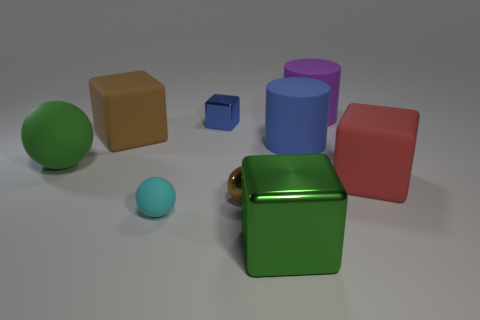The cube that is the same color as the big ball is what size?
Offer a terse response. Large. There is a large metallic object that is the same color as the big ball; what is its shape?
Give a very brief answer. Cube. Do the brown thing that is in front of the big brown cube and the cyan rubber object have the same shape?
Provide a short and direct response. Yes. What is the material of the small blue cube that is behind the large green matte object?
Make the answer very short. Metal. What number of matte objects are blue things or red cubes?
Your response must be concise. 2. Are there any yellow blocks of the same size as the green block?
Your response must be concise. No. Is the number of small cyan rubber balls in front of the brown matte block greater than the number of purple cylinders?
Your response must be concise. No. What number of small objects are cyan rubber balls or green rubber cylinders?
Offer a terse response. 1. How many big brown matte objects have the same shape as the cyan thing?
Give a very brief answer. 0. The green object that is on the left side of the metallic block left of the large metallic object is made of what material?
Provide a succinct answer. Rubber. 